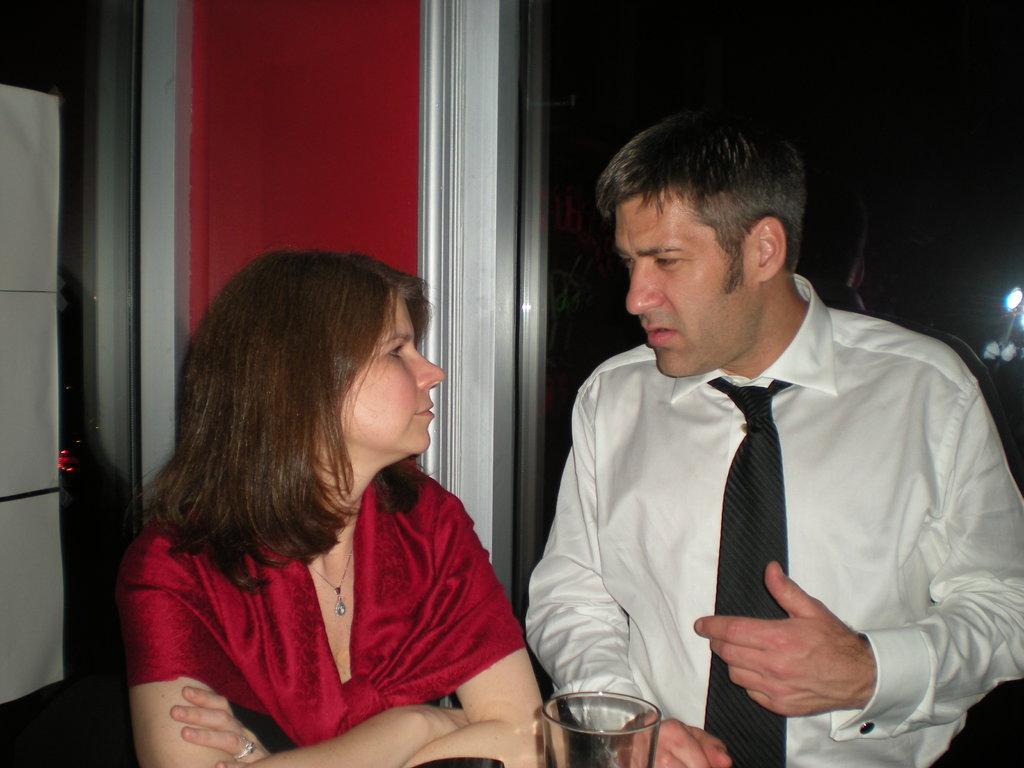Can you describe this image briefly? There are two persons,in front of these persons we can see glass. We can see papers on glass. On the background we can see person and lights. 